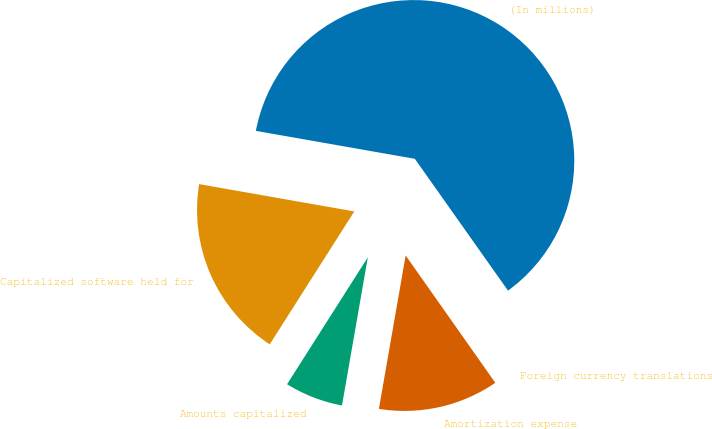Convert chart. <chart><loc_0><loc_0><loc_500><loc_500><pie_chart><fcel>(In millions)<fcel>Capitalized software held for<fcel>Amounts capitalized<fcel>Amortization expense<fcel>Foreign currency translations<nl><fcel>62.43%<fcel>18.75%<fcel>6.27%<fcel>12.51%<fcel>0.03%<nl></chart> 